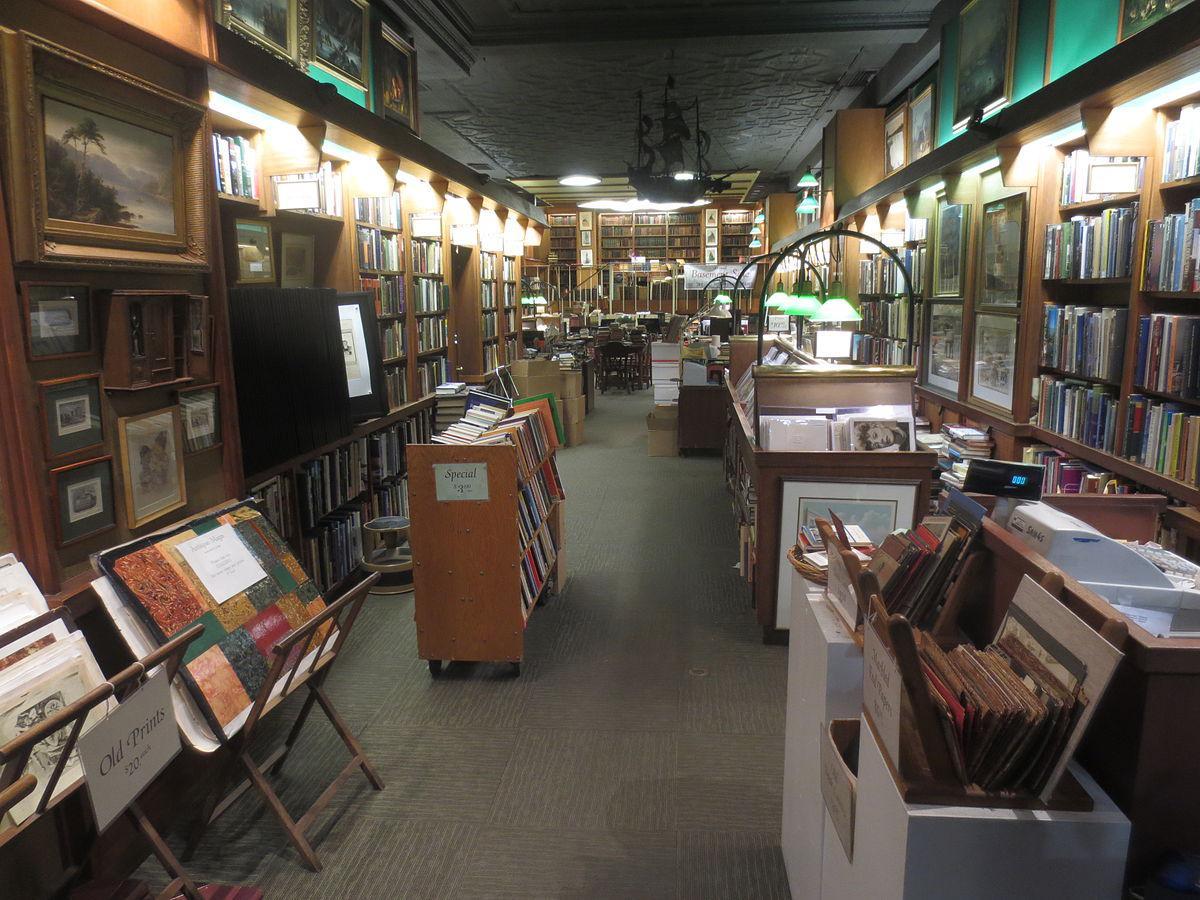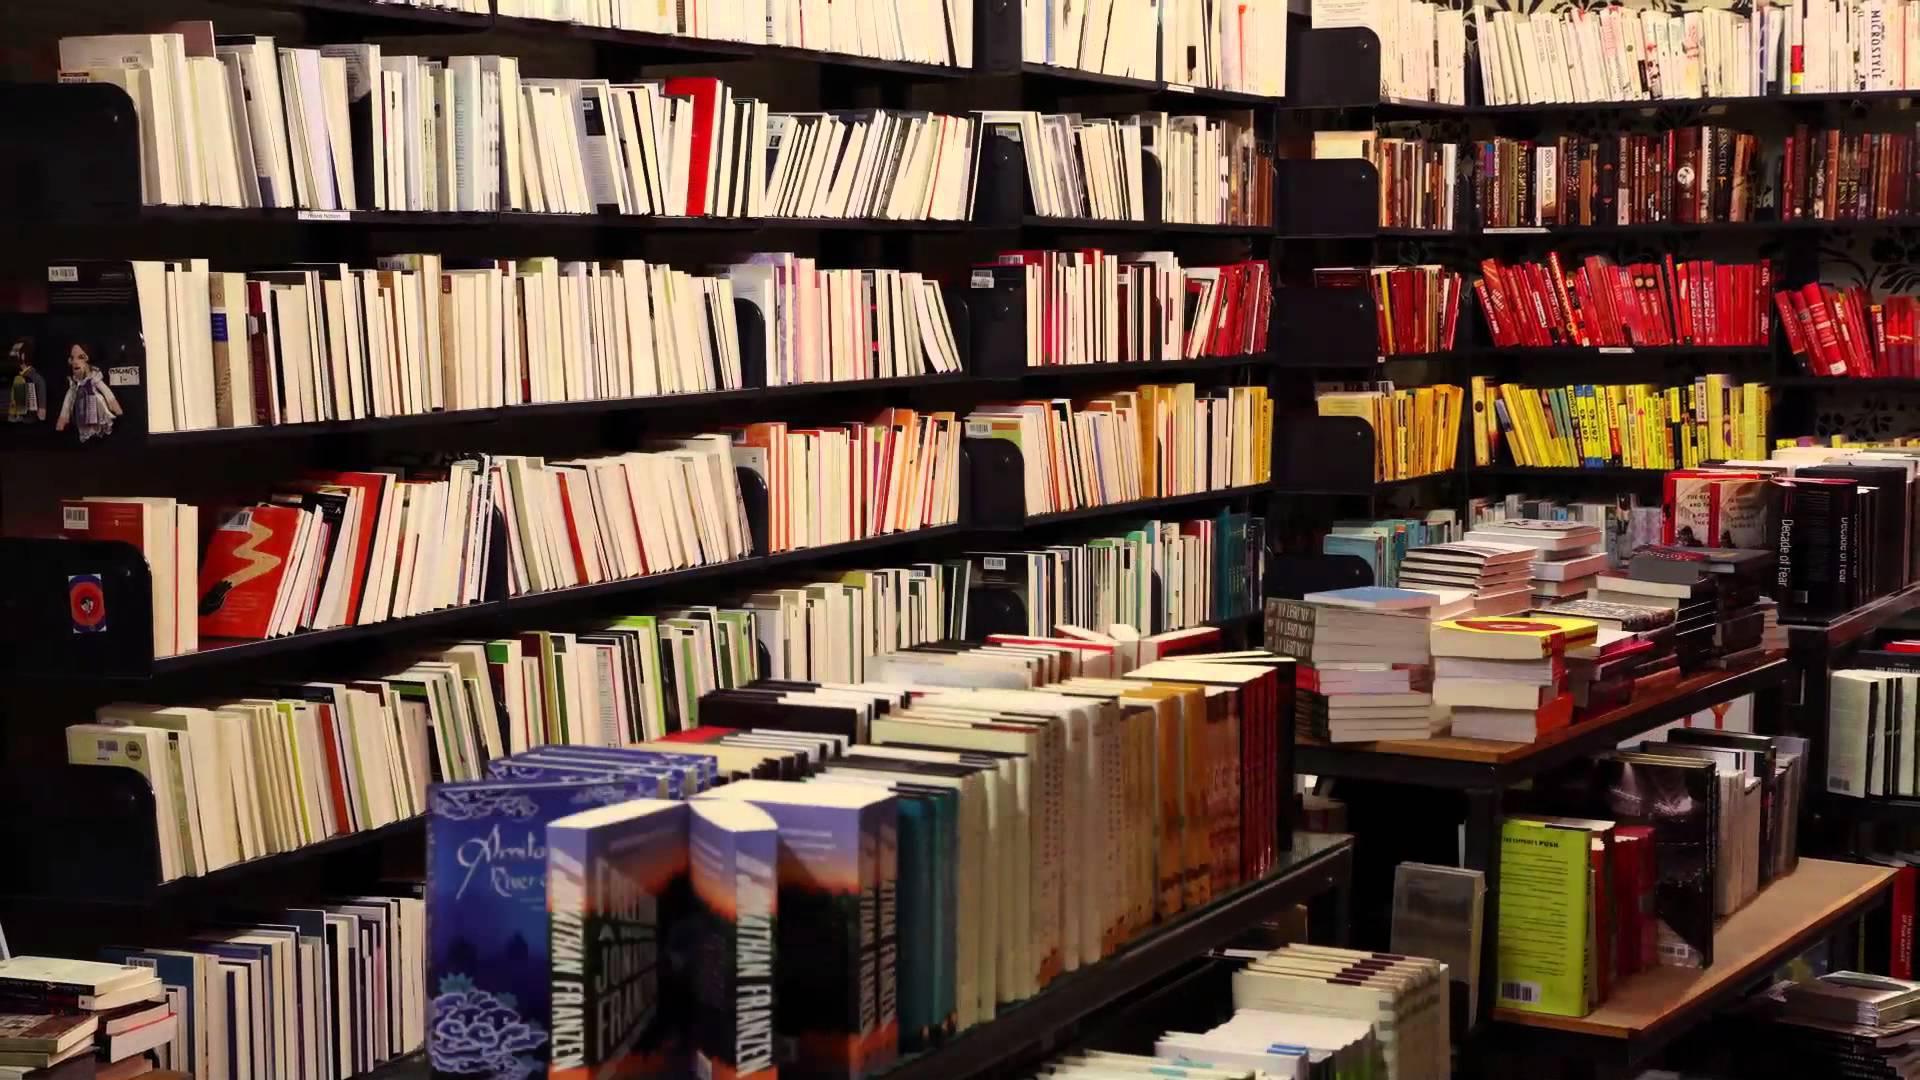The first image is the image on the left, the second image is the image on the right. Considering the images on both sides, is "An image shows the exterior of a bookstore with yellow-background signs above the entrance and running vertically beside a door." valid? Answer yes or no. No. The first image is the image on the left, the second image is the image on the right. Evaluate the accuracy of this statement regarding the images: "One of the images displays an outdoor sign, with vertical letters depicting a book store.". Is it true? Answer yes or no. No. 